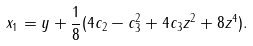<formula> <loc_0><loc_0><loc_500><loc_500>x _ { 1 } = y + \frac { 1 } { 8 } ( 4 c _ { 2 } - c _ { 3 } ^ { 2 } + 4 c _ { 3 } z ^ { 2 } + 8 z ^ { 4 } ) .</formula> 